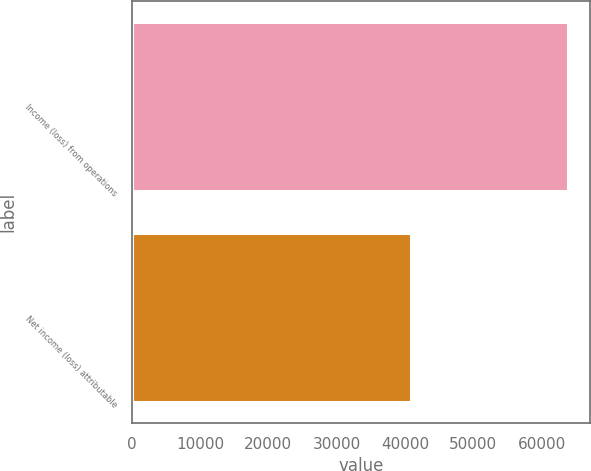Convert chart to OTSL. <chart><loc_0><loc_0><loc_500><loc_500><bar_chart><fcel>Income (loss) from operations<fcel>Net income (loss) attributable<nl><fcel>63907<fcel>40868<nl></chart> 